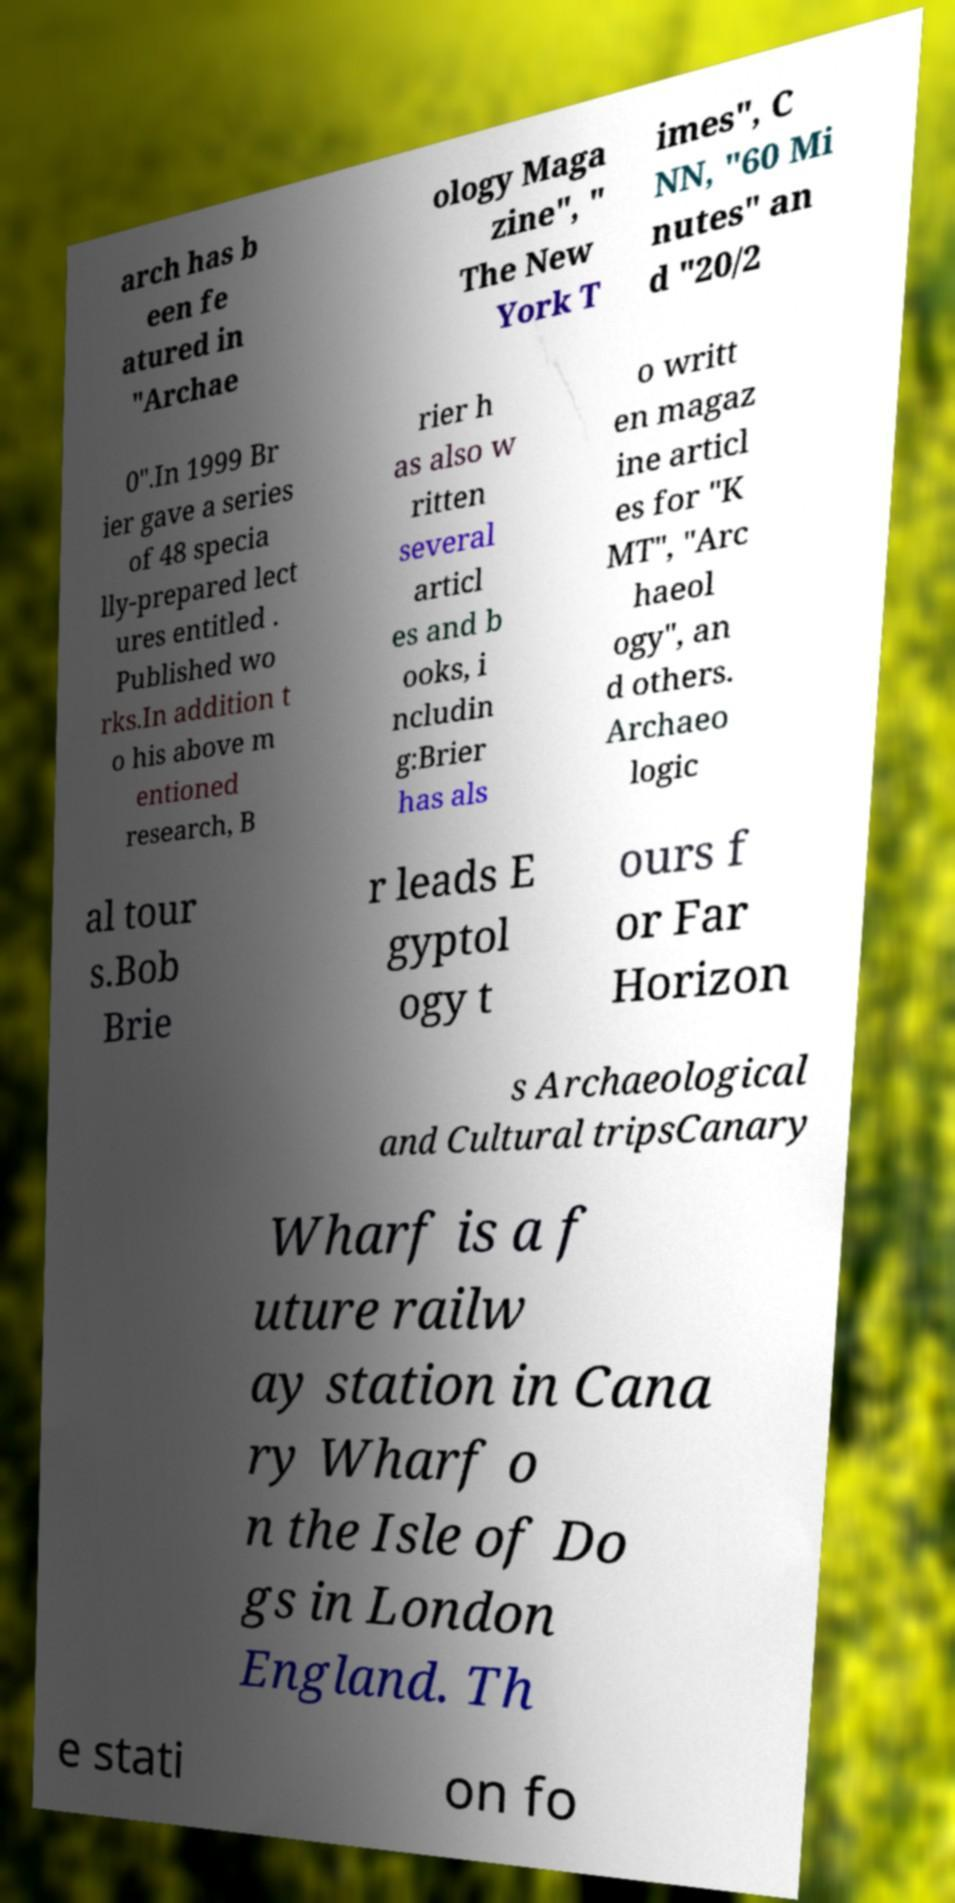Could you assist in decoding the text presented in this image and type it out clearly? arch has b een fe atured in "Archae ology Maga zine", " The New York T imes", C NN, "60 Mi nutes" an d "20/2 0".In 1999 Br ier gave a series of 48 specia lly-prepared lect ures entitled . Published wo rks.In addition t o his above m entioned research, B rier h as also w ritten several articl es and b ooks, i ncludin g:Brier has als o writt en magaz ine articl es for "K MT", "Arc haeol ogy", an d others. Archaeo logic al tour s.Bob Brie r leads E gyptol ogy t ours f or Far Horizon s Archaeological and Cultural tripsCanary Wharf is a f uture railw ay station in Cana ry Wharf o n the Isle of Do gs in London England. Th e stati on fo 